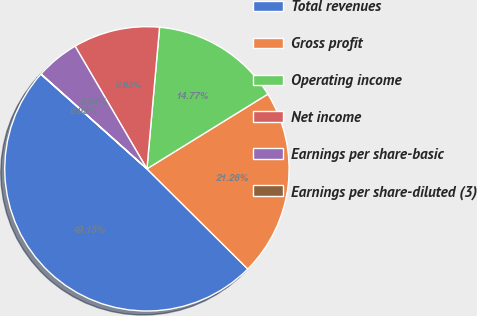<chart> <loc_0><loc_0><loc_500><loc_500><pie_chart><fcel>Total revenues<fcel>Gross profit<fcel>Operating income<fcel>Net income<fcel>Earnings per share-basic<fcel>Earnings per share-diluted (3)<nl><fcel>49.15%<fcel>21.26%<fcel>14.77%<fcel>9.85%<fcel>4.94%<fcel>0.03%<nl></chart> 